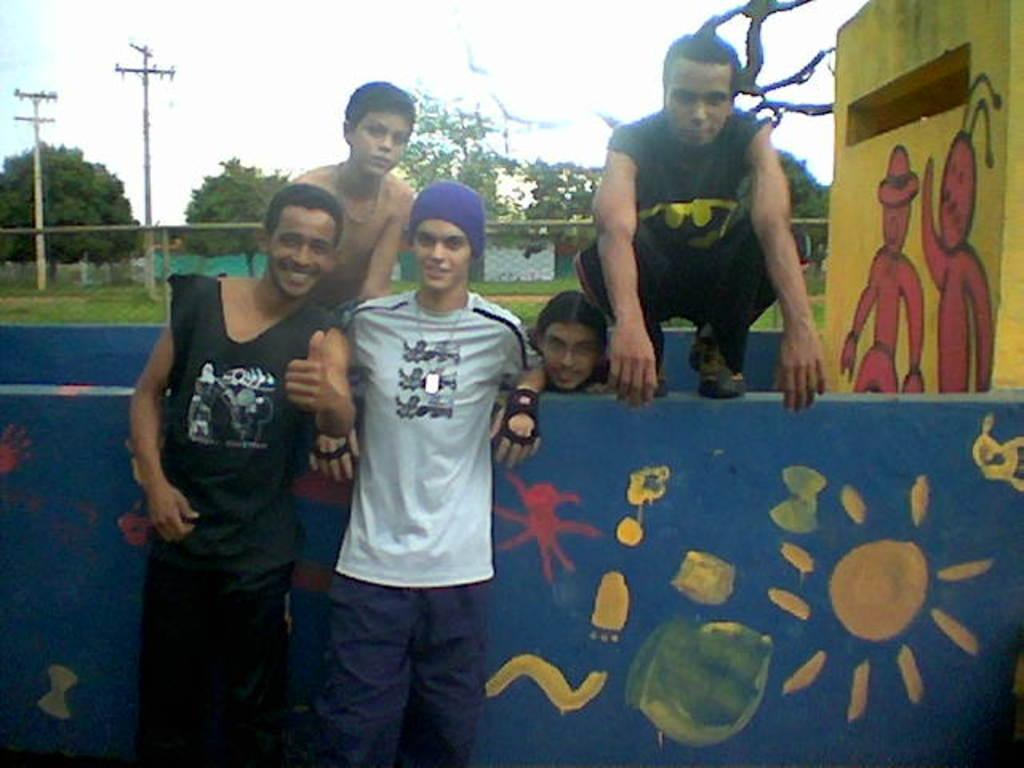What are the people in the image doing? The people in the image are standing on the ground and sitting on a wall. What can be seen in the background of the image? There are trees, electric poles, a sportsnet, walls, and the sky visible in the background of the image. What type of maid can be seen cleaning the circle in the image? There is no maid or circle present in the image. 